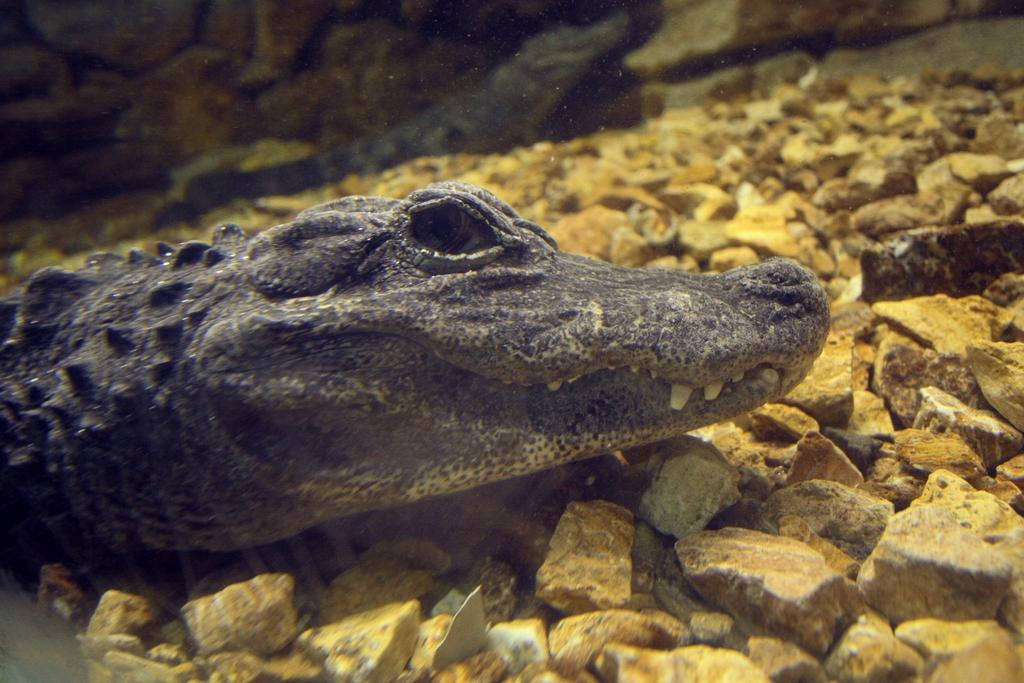What type of animal is in the image? There is a crocodile in the image. What is the crocodile's location in the image? The crocodile is on stones. What type of vehicle can be seen parked near the crocodile in the image? There is no vehicle present in the image; it only features a crocodile on stones. 